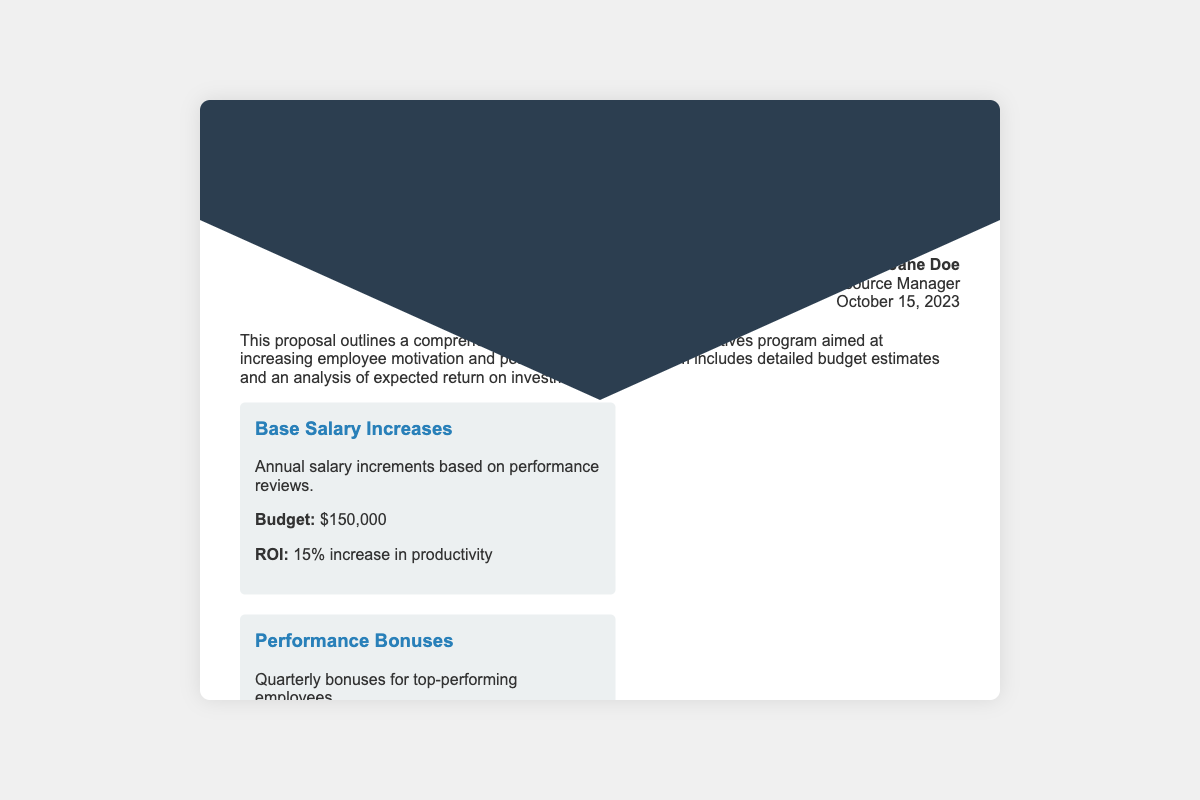What is the total budget for the program? The total budget is summarized at the end of the document and includes all listed financial incentives, totaling $750,000.
Answer: $750,000 What is the expected ROI from stock options? The expected ROI for the stock options is stated in the program details, indicating a 25% increase in long-term retention of key employees.
Answer: 25% Who is the author of the proposal? The author information section lists Jane Doe as the Human Resource Manager responsible for the proposal.
Answer: Jane Doe What is the budget for performance bonuses? The budget for performance bonuses is detailed in the program item for that category, which is set at $100,000.
Answer: $100,000 What is the expected ROI for profit sharing? The expected ROI for profit sharing is specified in the program details section as a 20% increase in employee engagement.
Answer: 20% What type of program does this document propose? The document proposes a financial rewards and incentives program aimed at increasing employee motivation and performance.
Answer: Financial rewards and incentives program How many program items are detailed in the proposal? The document details four specific program items designed to improve employee motivation and performance.
Answer: Four What is the publication date of the proposal? The author info section notes that the proposal was published on October 15, 2023.
Answer: October 15, 2023 What is the expected overall improvement in key performance metrics? The document concludes with total expected ROI showing an 85% overall improvement in key performance metrics.
Answer: 85% 